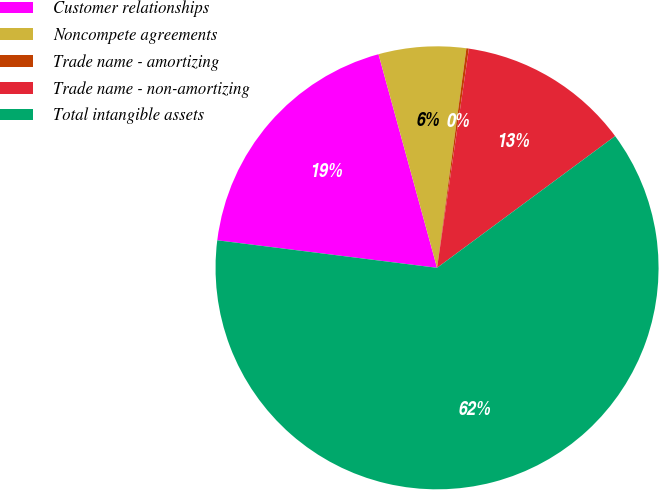Convert chart. <chart><loc_0><loc_0><loc_500><loc_500><pie_chart><fcel>Customer relationships<fcel>Noncompete agreements<fcel>Trade name - amortizing<fcel>Trade name - non-amortizing<fcel>Total intangible assets<nl><fcel>18.76%<fcel>6.37%<fcel>0.18%<fcel>12.57%<fcel>62.12%<nl></chart> 